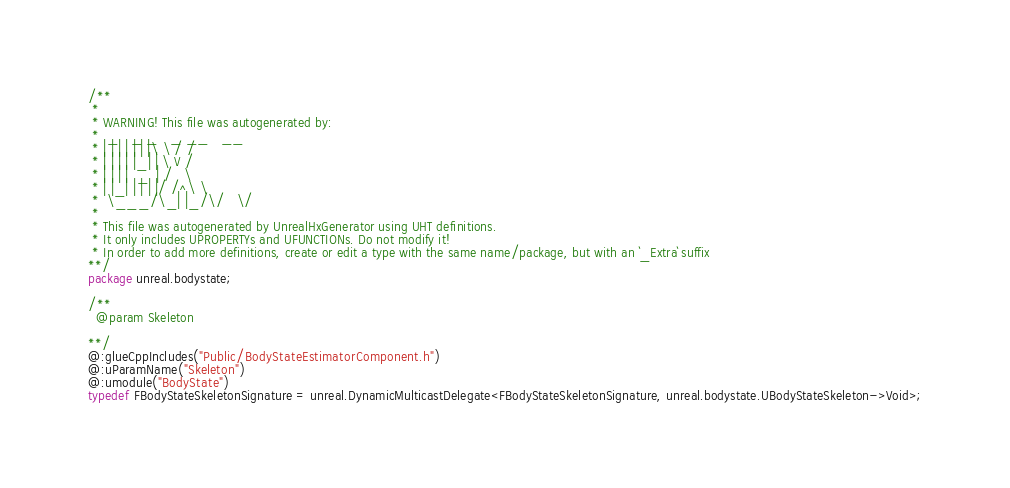Convert code to text. <code><loc_0><loc_0><loc_500><loc_500><_Haxe_>/**
 * 
 * WARNING! This file was autogenerated by: 
 *  _   _ _   _ __   __ 
 * | | | | | | |\ \ / / 
 * | | | | |_| | \ V /  
 * | | | |  _  | /   \  
 * | |_| | | | |/ /^\ \ 
 *  \___/\_| |_/\/   \/ 
 * 
 * This file was autogenerated by UnrealHxGenerator using UHT definitions.
 * It only includes UPROPERTYs and UFUNCTIONs. Do not modify it!
 * In order to add more definitions, create or edit a type with the same name/package, but with an `_Extra` suffix
**/
package unreal.bodystate;

/**
  @param Skeleton
  
**/
@:glueCppIncludes("Public/BodyStateEstimatorComponent.h")
@:uParamName("Skeleton")
@:umodule("BodyState")
typedef FBodyStateSkeletonSignature = unreal.DynamicMulticastDelegate<FBodyStateSkeletonSignature, unreal.bodystate.UBodyStateSkeleton->Void>;</code> 